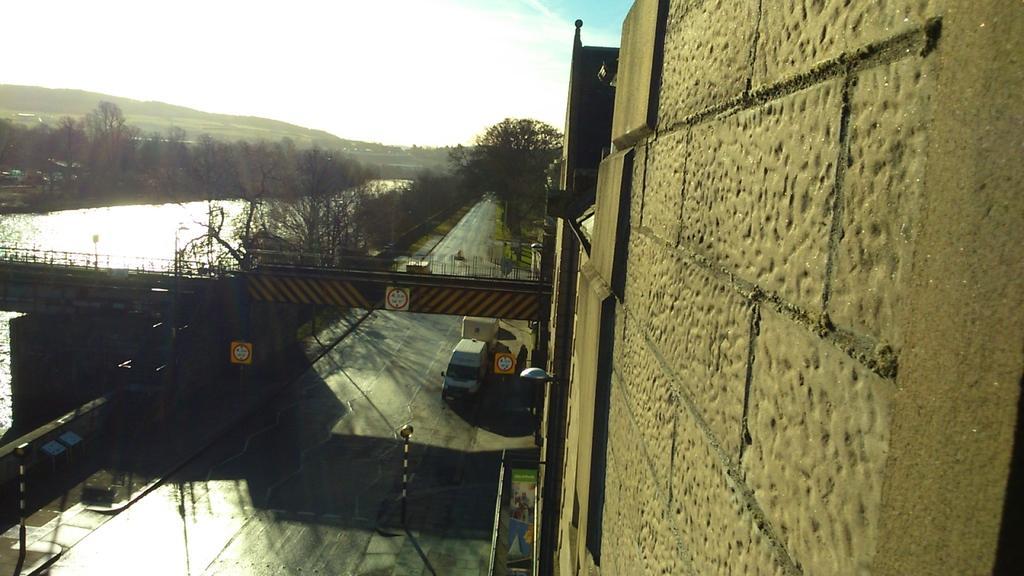Please provide a concise description of this image. In this picture there is a vehicle on the road. On the right side of the image there is a building. At the back there are trees and there is a mountain. On the left side of the image there is a bridge and there are poles on the footpath and there is a board on the building and there are boards on the poles. At the top there is sky and there are clouds. At the bottom there is water and there is a road. 